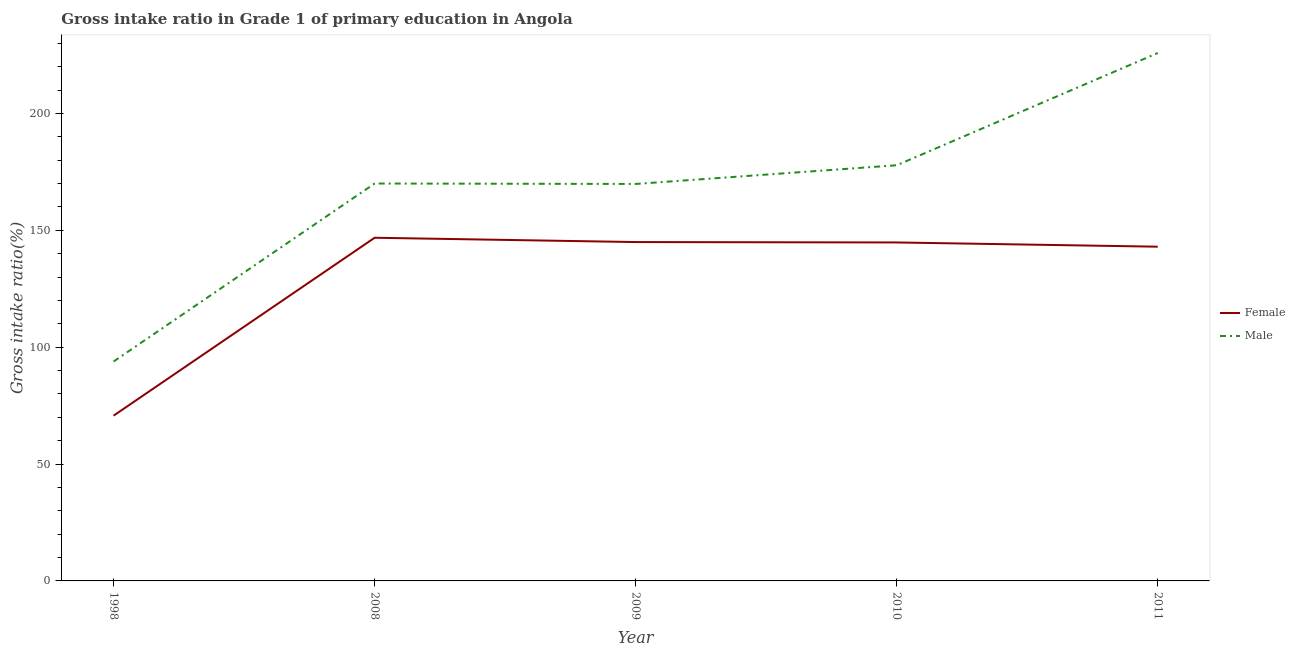How many different coloured lines are there?
Your answer should be very brief. 2. Is the number of lines equal to the number of legend labels?
Provide a succinct answer. Yes. What is the gross intake ratio(female) in 1998?
Your answer should be compact. 70.72. Across all years, what is the maximum gross intake ratio(male)?
Provide a succinct answer. 225.89. Across all years, what is the minimum gross intake ratio(male)?
Ensure brevity in your answer.  93.9. In which year was the gross intake ratio(female) maximum?
Ensure brevity in your answer.  2008. In which year was the gross intake ratio(female) minimum?
Provide a succinct answer. 1998. What is the total gross intake ratio(male) in the graph?
Provide a short and direct response. 837.55. What is the difference between the gross intake ratio(male) in 2010 and that in 2011?
Keep it short and to the point. -48.03. What is the difference between the gross intake ratio(female) in 1998 and the gross intake ratio(male) in 2008?
Keep it short and to the point. -99.32. What is the average gross intake ratio(male) per year?
Ensure brevity in your answer.  167.51. In the year 1998, what is the difference between the gross intake ratio(male) and gross intake ratio(female)?
Your answer should be compact. 23.17. What is the ratio of the gross intake ratio(male) in 1998 to that in 2008?
Your answer should be very brief. 0.55. Is the difference between the gross intake ratio(female) in 2008 and 2010 greater than the difference between the gross intake ratio(male) in 2008 and 2010?
Your answer should be very brief. Yes. What is the difference between the highest and the second highest gross intake ratio(male)?
Provide a short and direct response. 48.03. What is the difference between the highest and the lowest gross intake ratio(male)?
Provide a short and direct response. 131.99. Is the sum of the gross intake ratio(female) in 1998 and 2010 greater than the maximum gross intake ratio(male) across all years?
Give a very brief answer. No. Is the gross intake ratio(female) strictly less than the gross intake ratio(male) over the years?
Your answer should be very brief. Yes. Does the graph contain grids?
Your answer should be compact. No. Where does the legend appear in the graph?
Ensure brevity in your answer.  Center right. How are the legend labels stacked?
Your response must be concise. Vertical. What is the title of the graph?
Make the answer very short. Gross intake ratio in Grade 1 of primary education in Angola. Does "% of GNI" appear as one of the legend labels in the graph?
Offer a terse response. No. What is the label or title of the X-axis?
Give a very brief answer. Year. What is the label or title of the Y-axis?
Keep it short and to the point. Gross intake ratio(%). What is the Gross intake ratio(%) in Female in 1998?
Offer a very short reply. 70.72. What is the Gross intake ratio(%) in Male in 1998?
Make the answer very short. 93.9. What is the Gross intake ratio(%) of Female in 2008?
Make the answer very short. 146.84. What is the Gross intake ratio(%) in Male in 2008?
Your response must be concise. 170.04. What is the Gross intake ratio(%) in Female in 2009?
Your response must be concise. 144.99. What is the Gross intake ratio(%) of Male in 2009?
Offer a terse response. 169.86. What is the Gross intake ratio(%) of Female in 2010?
Your answer should be compact. 144.83. What is the Gross intake ratio(%) in Male in 2010?
Offer a very short reply. 177.86. What is the Gross intake ratio(%) in Female in 2011?
Offer a terse response. 143.02. What is the Gross intake ratio(%) of Male in 2011?
Ensure brevity in your answer.  225.89. Across all years, what is the maximum Gross intake ratio(%) in Female?
Offer a very short reply. 146.84. Across all years, what is the maximum Gross intake ratio(%) in Male?
Give a very brief answer. 225.89. Across all years, what is the minimum Gross intake ratio(%) in Female?
Your answer should be very brief. 70.72. Across all years, what is the minimum Gross intake ratio(%) of Male?
Ensure brevity in your answer.  93.9. What is the total Gross intake ratio(%) in Female in the graph?
Your answer should be very brief. 650.4. What is the total Gross intake ratio(%) of Male in the graph?
Your answer should be very brief. 837.55. What is the difference between the Gross intake ratio(%) in Female in 1998 and that in 2008?
Provide a short and direct response. -76.11. What is the difference between the Gross intake ratio(%) of Male in 1998 and that in 2008?
Make the answer very short. -76.15. What is the difference between the Gross intake ratio(%) of Female in 1998 and that in 2009?
Your answer should be very brief. -74.27. What is the difference between the Gross intake ratio(%) in Male in 1998 and that in 2009?
Provide a short and direct response. -75.97. What is the difference between the Gross intake ratio(%) of Female in 1998 and that in 2010?
Provide a succinct answer. -74.1. What is the difference between the Gross intake ratio(%) of Male in 1998 and that in 2010?
Offer a very short reply. -83.97. What is the difference between the Gross intake ratio(%) in Female in 1998 and that in 2011?
Give a very brief answer. -72.29. What is the difference between the Gross intake ratio(%) in Male in 1998 and that in 2011?
Provide a succinct answer. -131.99. What is the difference between the Gross intake ratio(%) of Female in 2008 and that in 2009?
Provide a succinct answer. 1.84. What is the difference between the Gross intake ratio(%) of Male in 2008 and that in 2009?
Offer a very short reply. 0.18. What is the difference between the Gross intake ratio(%) in Female in 2008 and that in 2010?
Your answer should be very brief. 2.01. What is the difference between the Gross intake ratio(%) of Male in 2008 and that in 2010?
Your response must be concise. -7.82. What is the difference between the Gross intake ratio(%) in Female in 2008 and that in 2011?
Provide a short and direct response. 3.82. What is the difference between the Gross intake ratio(%) of Male in 2008 and that in 2011?
Make the answer very short. -55.85. What is the difference between the Gross intake ratio(%) in Female in 2009 and that in 2010?
Your answer should be very brief. 0.16. What is the difference between the Gross intake ratio(%) in Male in 2009 and that in 2010?
Provide a succinct answer. -8. What is the difference between the Gross intake ratio(%) of Female in 2009 and that in 2011?
Provide a short and direct response. 1.98. What is the difference between the Gross intake ratio(%) of Male in 2009 and that in 2011?
Offer a very short reply. -56.03. What is the difference between the Gross intake ratio(%) of Female in 2010 and that in 2011?
Your answer should be very brief. 1.81. What is the difference between the Gross intake ratio(%) in Male in 2010 and that in 2011?
Provide a succinct answer. -48.03. What is the difference between the Gross intake ratio(%) of Female in 1998 and the Gross intake ratio(%) of Male in 2008?
Give a very brief answer. -99.32. What is the difference between the Gross intake ratio(%) in Female in 1998 and the Gross intake ratio(%) in Male in 2009?
Ensure brevity in your answer.  -99.14. What is the difference between the Gross intake ratio(%) of Female in 1998 and the Gross intake ratio(%) of Male in 2010?
Your answer should be very brief. -107.14. What is the difference between the Gross intake ratio(%) of Female in 1998 and the Gross intake ratio(%) of Male in 2011?
Offer a very short reply. -155.16. What is the difference between the Gross intake ratio(%) of Female in 2008 and the Gross intake ratio(%) of Male in 2009?
Your answer should be very brief. -23.03. What is the difference between the Gross intake ratio(%) of Female in 2008 and the Gross intake ratio(%) of Male in 2010?
Make the answer very short. -31.03. What is the difference between the Gross intake ratio(%) of Female in 2008 and the Gross intake ratio(%) of Male in 2011?
Ensure brevity in your answer.  -79.05. What is the difference between the Gross intake ratio(%) in Female in 2009 and the Gross intake ratio(%) in Male in 2010?
Offer a terse response. -32.87. What is the difference between the Gross intake ratio(%) of Female in 2009 and the Gross intake ratio(%) of Male in 2011?
Offer a very short reply. -80.9. What is the difference between the Gross intake ratio(%) in Female in 2010 and the Gross intake ratio(%) in Male in 2011?
Offer a very short reply. -81.06. What is the average Gross intake ratio(%) in Female per year?
Provide a succinct answer. 130.08. What is the average Gross intake ratio(%) of Male per year?
Your response must be concise. 167.51. In the year 1998, what is the difference between the Gross intake ratio(%) in Female and Gross intake ratio(%) in Male?
Provide a succinct answer. -23.17. In the year 2008, what is the difference between the Gross intake ratio(%) of Female and Gross intake ratio(%) of Male?
Offer a terse response. -23.21. In the year 2009, what is the difference between the Gross intake ratio(%) of Female and Gross intake ratio(%) of Male?
Offer a very short reply. -24.87. In the year 2010, what is the difference between the Gross intake ratio(%) in Female and Gross intake ratio(%) in Male?
Give a very brief answer. -33.03. In the year 2011, what is the difference between the Gross intake ratio(%) in Female and Gross intake ratio(%) in Male?
Provide a short and direct response. -82.87. What is the ratio of the Gross intake ratio(%) in Female in 1998 to that in 2008?
Give a very brief answer. 0.48. What is the ratio of the Gross intake ratio(%) in Male in 1998 to that in 2008?
Ensure brevity in your answer.  0.55. What is the ratio of the Gross intake ratio(%) in Female in 1998 to that in 2009?
Your response must be concise. 0.49. What is the ratio of the Gross intake ratio(%) of Male in 1998 to that in 2009?
Your response must be concise. 0.55. What is the ratio of the Gross intake ratio(%) of Female in 1998 to that in 2010?
Ensure brevity in your answer.  0.49. What is the ratio of the Gross intake ratio(%) in Male in 1998 to that in 2010?
Keep it short and to the point. 0.53. What is the ratio of the Gross intake ratio(%) in Female in 1998 to that in 2011?
Make the answer very short. 0.49. What is the ratio of the Gross intake ratio(%) of Male in 1998 to that in 2011?
Provide a succinct answer. 0.42. What is the ratio of the Gross intake ratio(%) in Female in 2008 to that in 2009?
Your response must be concise. 1.01. What is the ratio of the Gross intake ratio(%) in Female in 2008 to that in 2010?
Give a very brief answer. 1.01. What is the ratio of the Gross intake ratio(%) of Male in 2008 to that in 2010?
Provide a succinct answer. 0.96. What is the ratio of the Gross intake ratio(%) of Female in 2008 to that in 2011?
Your answer should be very brief. 1.03. What is the ratio of the Gross intake ratio(%) of Male in 2008 to that in 2011?
Offer a terse response. 0.75. What is the ratio of the Gross intake ratio(%) of Male in 2009 to that in 2010?
Offer a very short reply. 0.95. What is the ratio of the Gross intake ratio(%) of Female in 2009 to that in 2011?
Your answer should be compact. 1.01. What is the ratio of the Gross intake ratio(%) of Male in 2009 to that in 2011?
Your response must be concise. 0.75. What is the ratio of the Gross intake ratio(%) in Female in 2010 to that in 2011?
Your response must be concise. 1.01. What is the ratio of the Gross intake ratio(%) of Male in 2010 to that in 2011?
Make the answer very short. 0.79. What is the difference between the highest and the second highest Gross intake ratio(%) in Female?
Your answer should be very brief. 1.84. What is the difference between the highest and the second highest Gross intake ratio(%) of Male?
Offer a terse response. 48.03. What is the difference between the highest and the lowest Gross intake ratio(%) of Female?
Keep it short and to the point. 76.11. What is the difference between the highest and the lowest Gross intake ratio(%) of Male?
Make the answer very short. 131.99. 